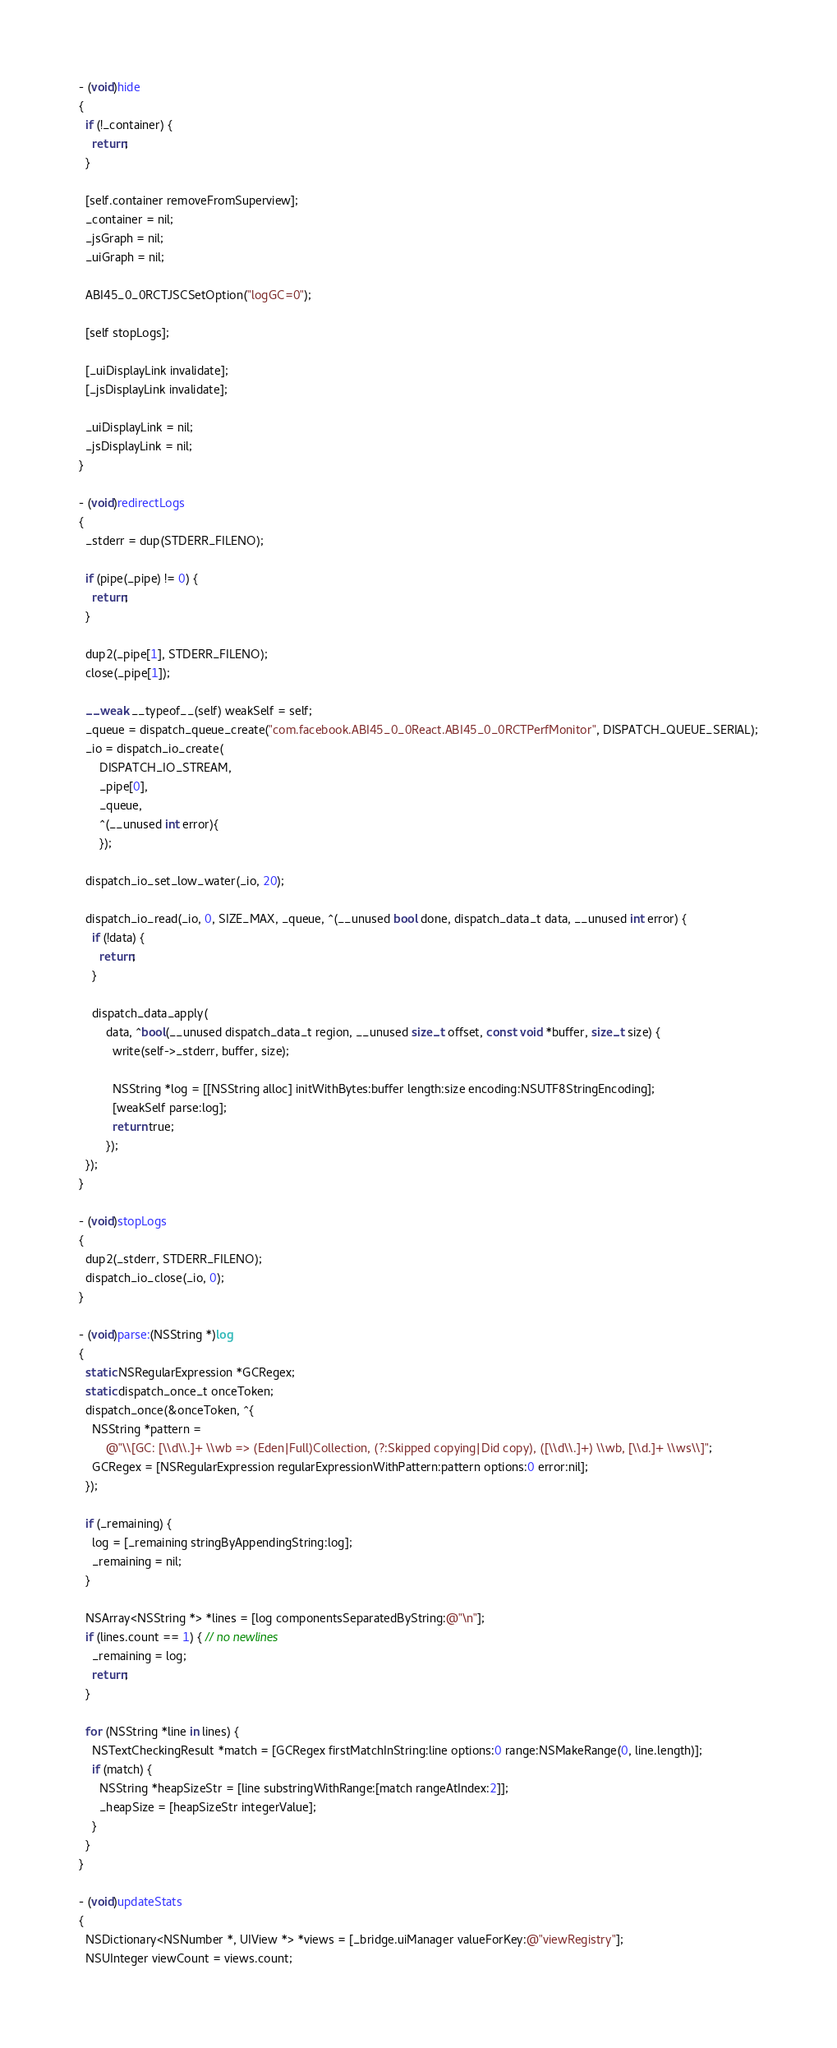<code> <loc_0><loc_0><loc_500><loc_500><_ObjectiveC_>- (void)hide
{
  if (!_container) {
    return;
  }

  [self.container removeFromSuperview];
  _container = nil;
  _jsGraph = nil;
  _uiGraph = nil;

  ABI45_0_0RCTJSCSetOption("logGC=0");

  [self stopLogs];

  [_uiDisplayLink invalidate];
  [_jsDisplayLink invalidate];

  _uiDisplayLink = nil;
  _jsDisplayLink = nil;
}

- (void)redirectLogs
{
  _stderr = dup(STDERR_FILENO);

  if (pipe(_pipe) != 0) {
    return;
  }

  dup2(_pipe[1], STDERR_FILENO);
  close(_pipe[1]);

  __weak __typeof__(self) weakSelf = self;
  _queue = dispatch_queue_create("com.facebook.ABI45_0_0React.ABI45_0_0RCTPerfMonitor", DISPATCH_QUEUE_SERIAL);
  _io = dispatch_io_create(
      DISPATCH_IO_STREAM,
      _pipe[0],
      _queue,
      ^(__unused int error){
      });

  dispatch_io_set_low_water(_io, 20);

  dispatch_io_read(_io, 0, SIZE_MAX, _queue, ^(__unused bool done, dispatch_data_t data, __unused int error) {
    if (!data) {
      return;
    }

    dispatch_data_apply(
        data, ^bool(__unused dispatch_data_t region, __unused size_t offset, const void *buffer, size_t size) {
          write(self->_stderr, buffer, size);

          NSString *log = [[NSString alloc] initWithBytes:buffer length:size encoding:NSUTF8StringEncoding];
          [weakSelf parse:log];
          return true;
        });
  });
}

- (void)stopLogs
{
  dup2(_stderr, STDERR_FILENO);
  dispatch_io_close(_io, 0);
}

- (void)parse:(NSString *)log
{
  static NSRegularExpression *GCRegex;
  static dispatch_once_t onceToken;
  dispatch_once(&onceToken, ^{
    NSString *pattern =
        @"\\[GC: [\\d\\.]+ \\wb => (Eden|Full)Collection, (?:Skipped copying|Did copy), ([\\d\\.]+) \\wb, [\\d.]+ \\ws\\]";
    GCRegex = [NSRegularExpression regularExpressionWithPattern:pattern options:0 error:nil];
  });

  if (_remaining) {
    log = [_remaining stringByAppendingString:log];
    _remaining = nil;
  }

  NSArray<NSString *> *lines = [log componentsSeparatedByString:@"\n"];
  if (lines.count == 1) { // no newlines
    _remaining = log;
    return;
  }

  for (NSString *line in lines) {
    NSTextCheckingResult *match = [GCRegex firstMatchInString:line options:0 range:NSMakeRange(0, line.length)];
    if (match) {
      NSString *heapSizeStr = [line substringWithRange:[match rangeAtIndex:2]];
      _heapSize = [heapSizeStr integerValue];
    }
  }
}

- (void)updateStats
{
  NSDictionary<NSNumber *, UIView *> *views = [_bridge.uiManager valueForKey:@"viewRegistry"];
  NSUInteger viewCount = views.count;</code> 